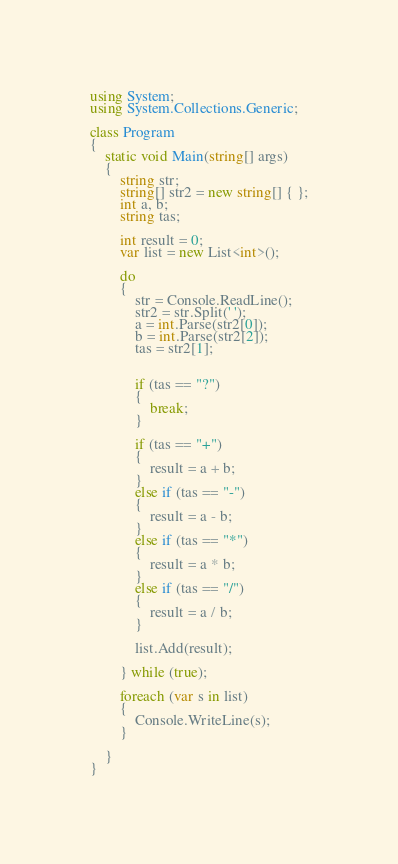Convert code to text. <code><loc_0><loc_0><loc_500><loc_500><_C#_>using System;
using System.Collections.Generic;

class Program
{
    static void Main(string[] args)
    {
        string str;
        string[] str2 = new string[] { };
        int a, b;
        string tas;
       
        int result = 0;
        var list = new List<int>();

        do
        {
            str = Console.ReadLine();
            str2 = str.Split(' ');
            a = int.Parse(str2[0]);
            b = int.Parse(str2[2]);
            tas = str2[1];


            if (tas == "?")
            {
                break;
            }

            if (tas == "+")
            {
                result = a + b;
            }
            else if (tas == "-")
            {
                result = a - b;
            }
            else if (tas == "*")
            {
                result = a * b;
            }
            else if (tas == "/")
            {
                result = a / b;
            }

            list.Add(result);

        } while (true);

        foreach (var s in list)
        {
            Console.WriteLine(s);
        }
        
    }
}
</code> 